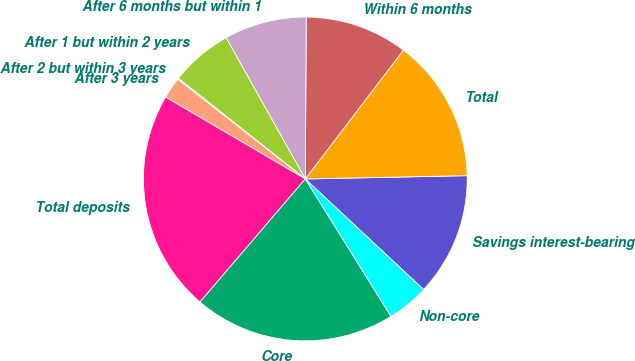Convert chart to OTSL. <chart><loc_0><loc_0><loc_500><loc_500><pie_chart><fcel>Savings interest-bearing<fcel>Total<fcel>Within 6 months<fcel>After 6 months but within 1<fcel>After 1 but within 2 years<fcel>After 2 but within 3 years<fcel>After 3 years<fcel>Total deposits<fcel>Core<fcel>Non-core<nl><fcel>12.29%<fcel>14.32%<fcel>10.26%<fcel>8.23%<fcel>6.2%<fcel>0.1%<fcel>2.13%<fcel>22.17%<fcel>20.14%<fcel>4.16%<nl></chart> 